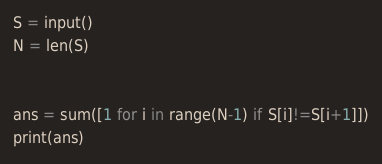Convert code to text. <code><loc_0><loc_0><loc_500><loc_500><_Python_>S = input()
N = len(S)


ans = sum([1 for i in range(N-1) if S[i]!=S[i+1]])
print(ans)</code> 